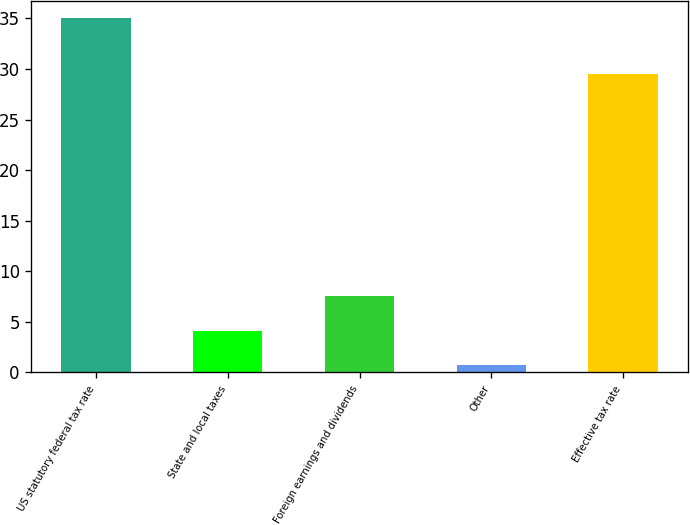Convert chart. <chart><loc_0><loc_0><loc_500><loc_500><bar_chart><fcel>US statutory federal tax rate<fcel>State and local taxes<fcel>Foreign earnings and dividends<fcel>Other<fcel>Effective tax rate<nl><fcel>35<fcel>4.13<fcel>7.56<fcel>0.7<fcel>29.5<nl></chart> 